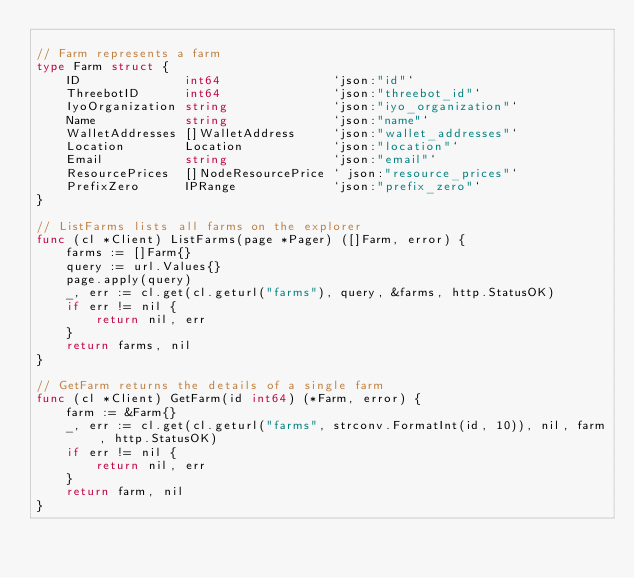<code> <loc_0><loc_0><loc_500><loc_500><_Go_>
// Farm represents a farm
type Farm struct {
	ID              int64               `json:"id"`
	ThreebotID      int64               `json:"threebot_id"`
	IyoOrganization string              `json:"iyo_organization"`
	Name            string              `json:"name"`
	WalletAddresses []WalletAddress     `json:"wallet_addresses"`
	Location        Location            `json:"location"`
	Email           string              `json:"email"`
	ResourcePrices  []NodeResourcePrice ` json:"resource_prices"`
	PrefixZero      IPRange             `json:"prefix_zero"`
}

// ListFarms lists all farms on the explorer
func (cl *Client) ListFarms(page *Pager) ([]Farm, error) {
	farms := []Farm{}
	query := url.Values{}
	page.apply(query)
	_, err := cl.get(cl.geturl("farms"), query, &farms, http.StatusOK)
	if err != nil {
		return nil, err
	}
	return farms, nil
}

// GetFarm returns the details of a single farm
func (cl *Client) GetFarm(id int64) (*Farm, error) {
	farm := &Farm{}
	_, err := cl.get(cl.geturl("farms", strconv.FormatInt(id, 10)), nil, farm, http.StatusOK)
	if err != nil {
		return nil, err
	}
	return farm, nil
}
</code> 